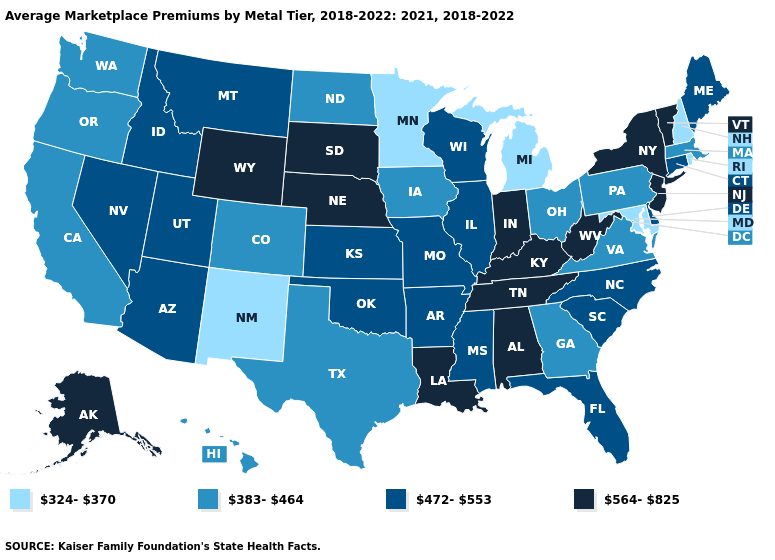Which states have the lowest value in the West?
Give a very brief answer. New Mexico. Name the states that have a value in the range 383-464?
Be succinct. California, Colorado, Georgia, Hawaii, Iowa, Massachusetts, North Dakota, Ohio, Oregon, Pennsylvania, Texas, Virginia, Washington. Name the states that have a value in the range 383-464?
Answer briefly. California, Colorado, Georgia, Hawaii, Iowa, Massachusetts, North Dakota, Ohio, Oregon, Pennsylvania, Texas, Virginia, Washington. What is the value of Delaware?
Quick response, please. 472-553. Name the states that have a value in the range 472-553?
Concise answer only. Arizona, Arkansas, Connecticut, Delaware, Florida, Idaho, Illinois, Kansas, Maine, Mississippi, Missouri, Montana, Nevada, North Carolina, Oklahoma, South Carolina, Utah, Wisconsin. Does Virginia have a higher value than Montana?
Short answer required. No. Among the states that border Virginia , which have the lowest value?
Short answer required. Maryland. How many symbols are there in the legend?
Answer briefly. 4. Does California have the lowest value in the USA?
Keep it brief. No. What is the value of Nevada?
Concise answer only. 472-553. Is the legend a continuous bar?
Answer briefly. No. What is the lowest value in the MidWest?
Keep it brief. 324-370. Does Tennessee have a lower value than Maryland?
Keep it brief. No. Name the states that have a value in the range 472-553?
Short answer required. Arizona, Arkansas, Connecticut, Delaware, Florida, Idaho, Illinois, Kansas, Maine, Mississippi, Missouri, Montana, Nevada, North Carolina, Oklahoma, South Carolina, Utah, Wisconsin. Among the states that border North Dakota , does Minnesota have the lowest value?
Short answer required. Yes. 